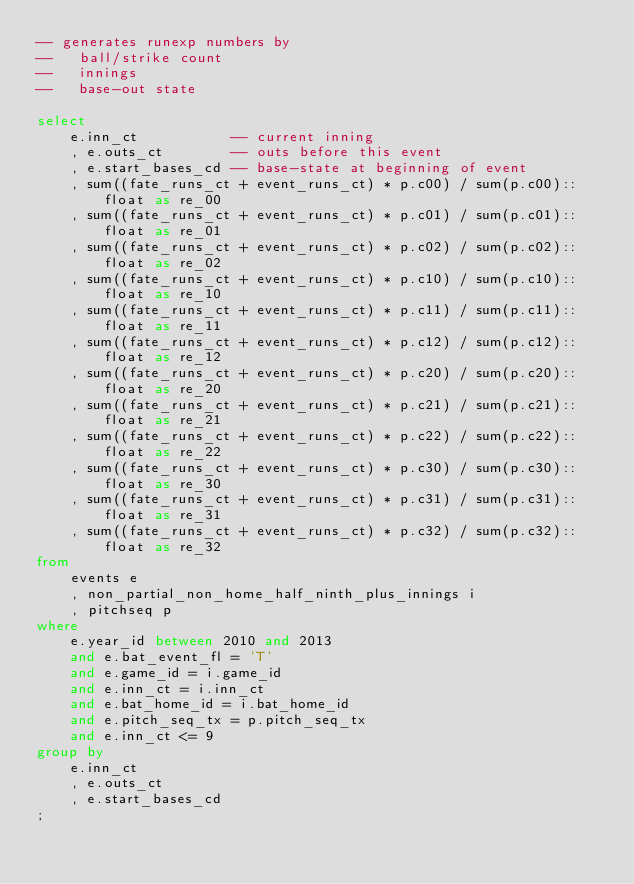<code> <loc_0><loc_0><loc_500><loc_500><_SQL_>-- generates runexp numbers by
--   ball/strike count
--   innings
--   base-out state

select
    e.inn_ct           -- current inning
    , e.outs_ct        -- outs before this event
    , e.start_bases_cd -- base-state at beginning of event
    , sum((fate_runs_ct + event_runs_ct) * p.c00) / sum(p.c00)::float as re_00
    , sum((fate_runs_ct + event_runs_ct) * p.c01) / sum(p.c01)::float as re_01
    , sum((fate_runs_ct + event_runs_ct) * p.c02) / sum(p.c02)::float as re_02
    , sum((fate_runs_ct + event_runs_ct) * p.c10) / sum(p.c10)::float as re_10
    , sum((fate_runs_ct + event_runs_ct) * p.c11) / sum(p.c11)::float as re_11
    , sum((fate_runs_ct + event_runs_ct) * p.c12) / sum(p.c12)::float as re_12
    , sum((fate_runs_ct + event_runs_ct) * p.c20) / sum(p.c20)::float as re_20
    , sum((fate_runs_ct + event_runs_ct) * p.c21) / sum(p.c21)::float as re_21
    , sum((fate_runs_ct + event_runs_ct) * p.c22) / sum(p.c22)::float as re_22
    , sum((fate_runs_ct + event_runs_ct) * p.c30) / sum(p.c30)::float as re_30
    , sum((fate_runs_ct + event_runs_ct) * p.c31) / sum(p.c31)::float as re_31
    , sum((fate_runs_ct + event_runs_ct) * p.c32) / sum(p.c32)::float as re_32
from
    events e
    , non_partial_non_home_half_ninth_plus_innings i
    , pitchseq p
where
    e.year_id between 2010 and 2013 
    and e.bat_event_fl = 'T'
    and e.game_id = i.game_id 
    and e.inn_ct = i.inn_ct 
    and e.bat_home_id = i.bat_home_id
    and e.pitch_seq_tx = p.pitch_seq_tx
    and e.inn_ct <= 9
group by
    e.inn_ct
    , e.outs_ct
    , e.start_bases_cd
;
</code> 